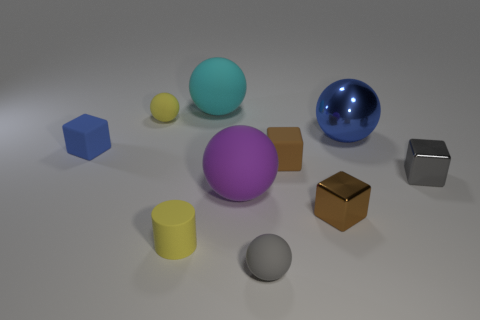What shapes can you identify in the image? I can see various geometric shapes including spheres, a cube, a cylinder, and what appears to be a rectangular prism. 